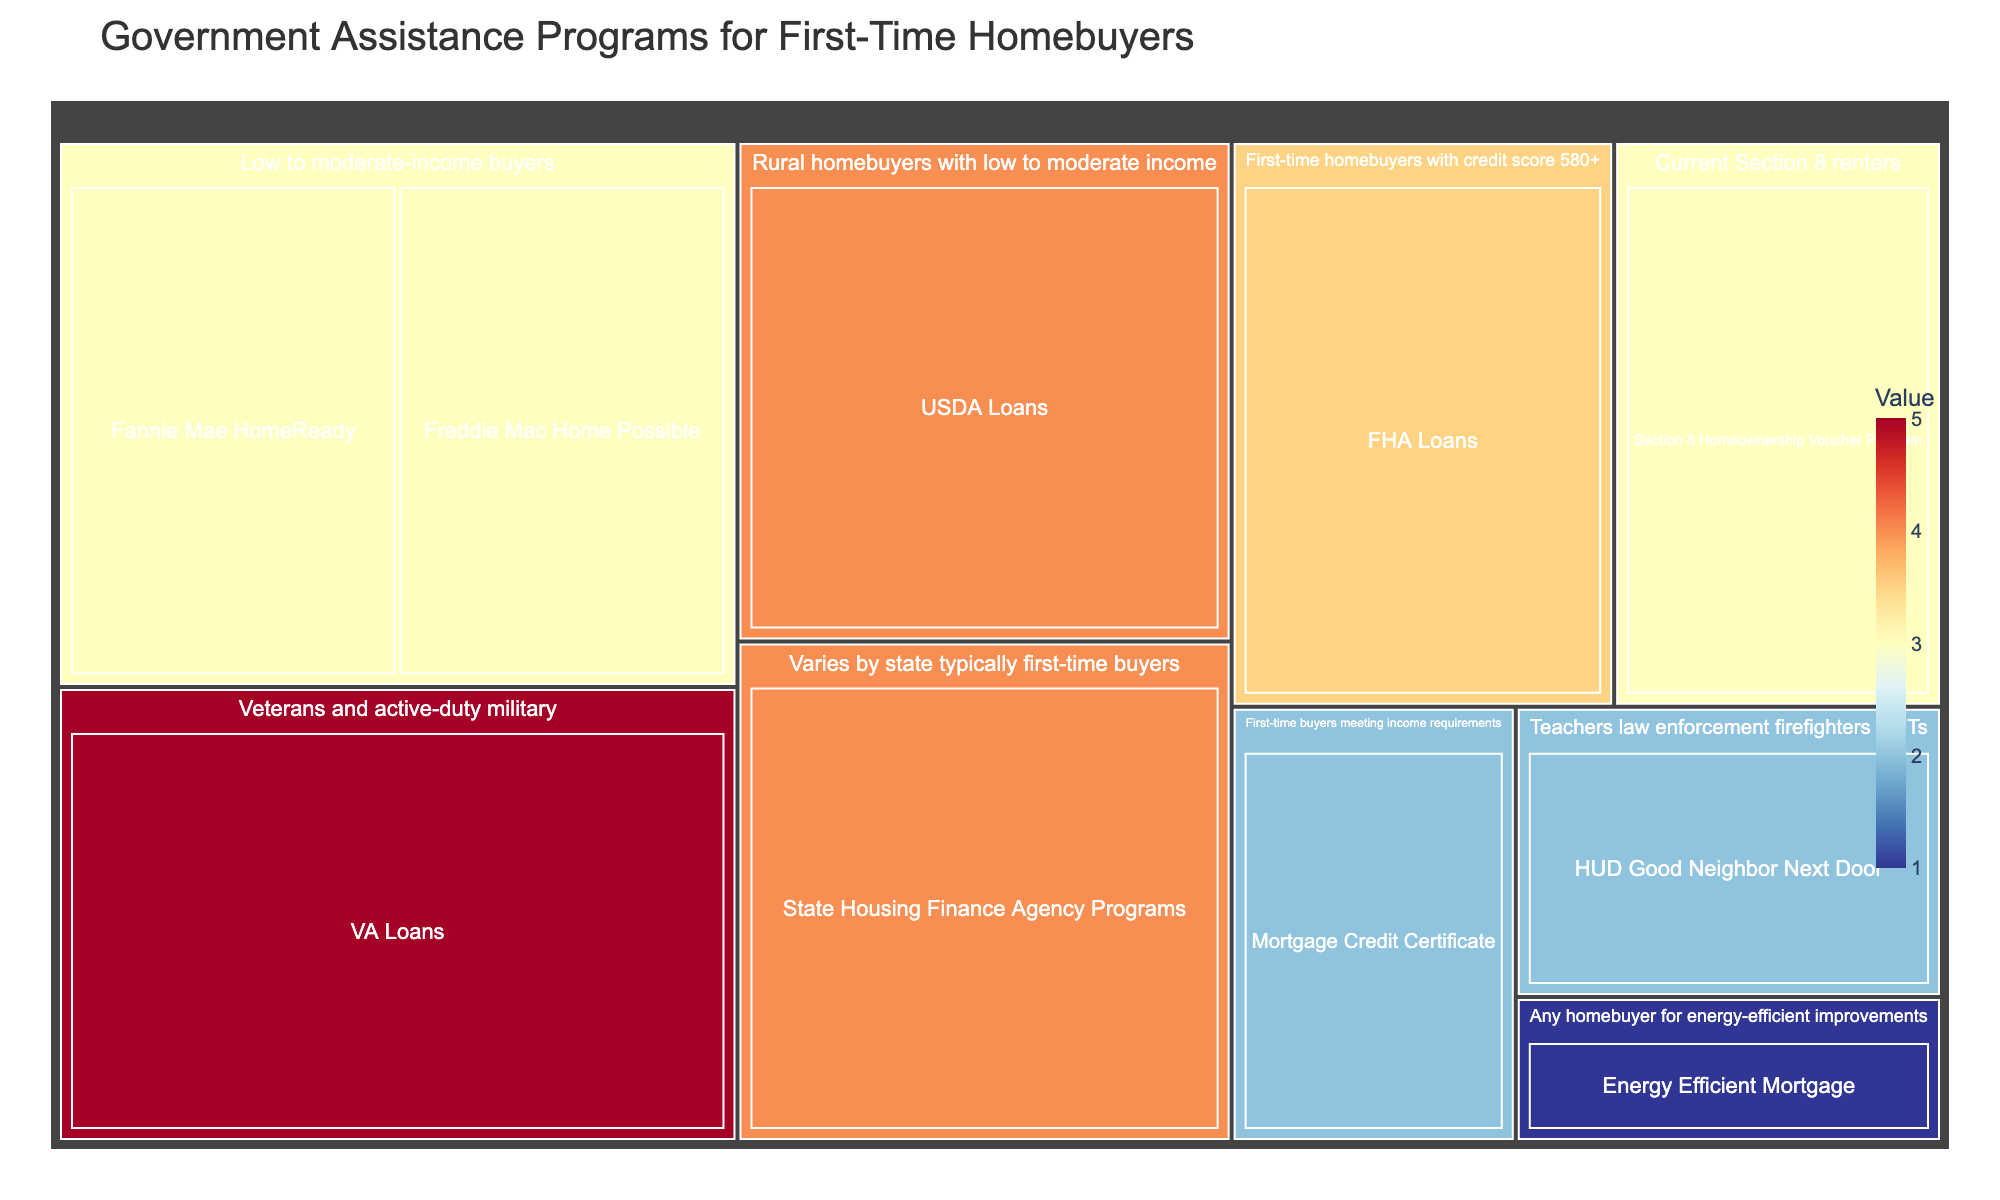What's the title of the figure? The title can be found at the top of the figure. It provides an overview of the content displayed.
Answer: Government Assistance Programs for First-Time Homebuyers Which program provides a 50% discount on HUD homes? You can identify this by looking at the 'Benefit Type' associated with each program.
Answer: HUD Good Neighbor Next Door How many programs offer 'Low down payment' as a benefit? Look for the programs that have 'Low down payment' in the 'Benefit Type'. Count each program that matches this benefit type.
Answer: 4 What is the combined value for all programs that offer 'No down payment required'? Find the values associated with the 'No down payment required' benefit type and sum them up. These programs are VA Loans and USDA Loans. The values are 5 and 4, respectively.
Answer: 9 Which eligibility category has the highest total value of programs? Sum the values for each eligibility category and compare. The categories are: 'First-time homebuyers with credit score 580+', 'Veterans and active-duty military', etc.
Answer: Varies by state typically first-time buyers (4+2+4) Which benefit type is associated with the 'Current Section 8 renters' eligibility criteria? Locate the eligibility criteria 'Current Section 8 renters' and read the 'Benefit Type' from the same branch of the treemap.
Answer: Monthly mortgage assistance Compare the program values for 'Low to moderate-income buyers.' Which one offers more value to the buyers? Compare the values for 'Fannie Mae HomeReady' and 'Freddie Mac Home Possible,' both targeting 'Low to moderate-income buyers.' Fannie Mae HomeReady has a value of 3, and Freddie Mac Home Possible also has a value of 3.
Answer: Both are equal at 3 Which program has the lowest value and what is its eligibility criteria? Identify the smallest value on the treemap and then find the corresponding program and its eligibility criteria.
Answer: Energy Efficient Mortgage; Any homebuyer for energy-efficient improvements If I am a veteran or an active-duty military member, which program should I consider for no down payment required? Look for the eligibility criteria 'Veterans and active-duty military' and identify the associated program with 'No down payment required.'
Answer: VA Loans 